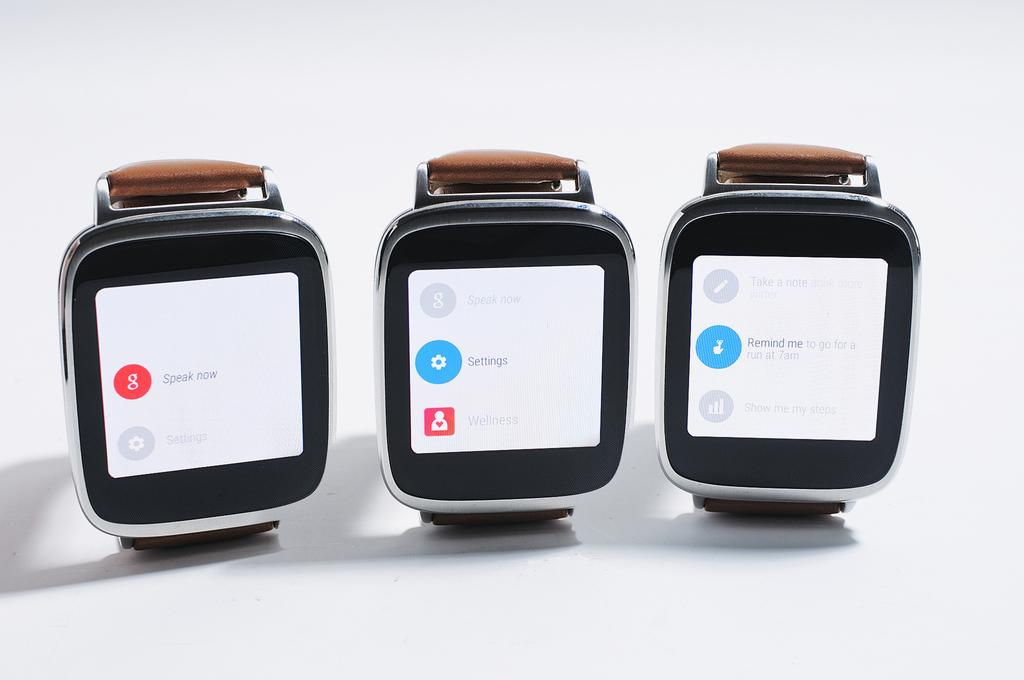<image>
Provide a brief description of the given image. A watch on the left shows the Google icon and instructions to speak now. 